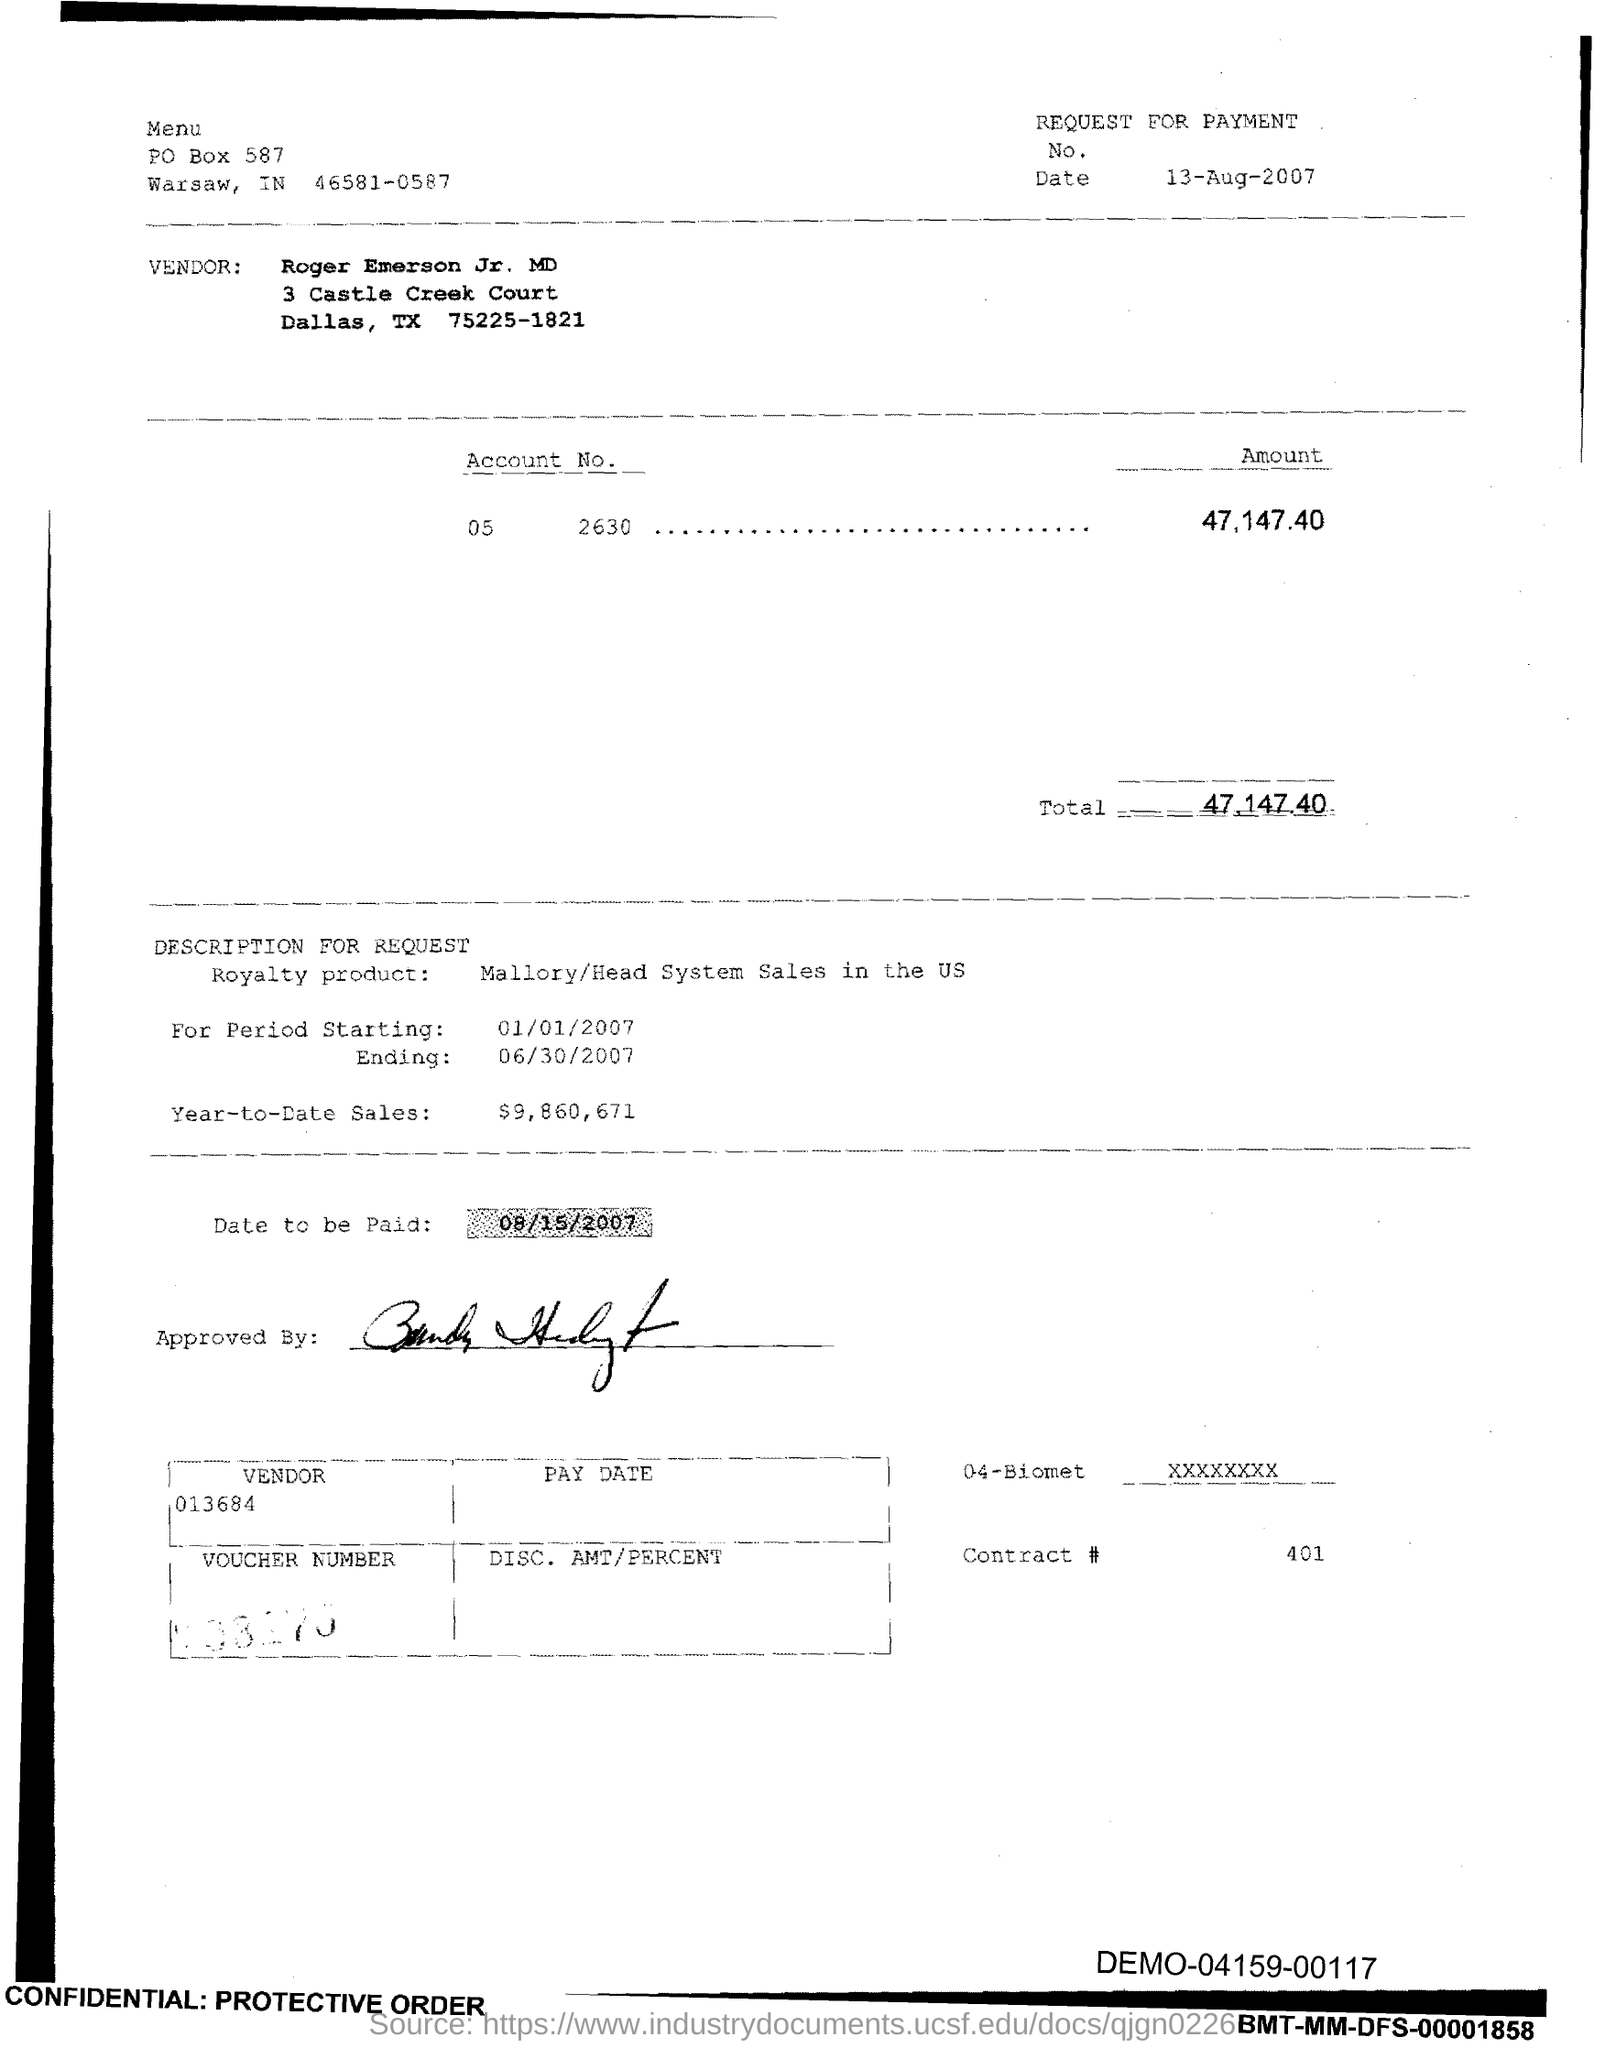Give some essential details in this illustration. The total is 47,147.40. The year-to-date sales as of the current date are $9,860,671. What is the Contract Number 401?" is a question that is being asked. 